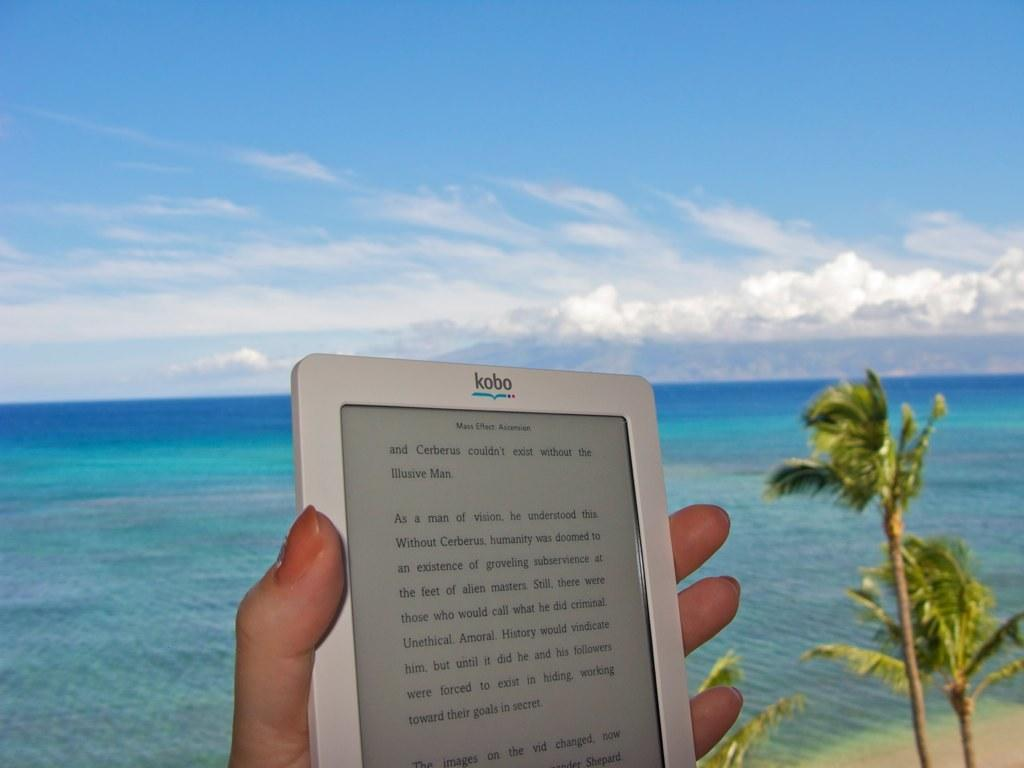What is the main subject of the image? There is a person in the image. What is the person holding in her hand? The person is holding a tablet in her hand. What type of natural environment is visible in the image? There are trees and an ocean visible in the image. What type of cloth is the person wearing in the image? The provided facts do not mention any clothing worn by the person, so we cannot determine the type of cloth in the image. 